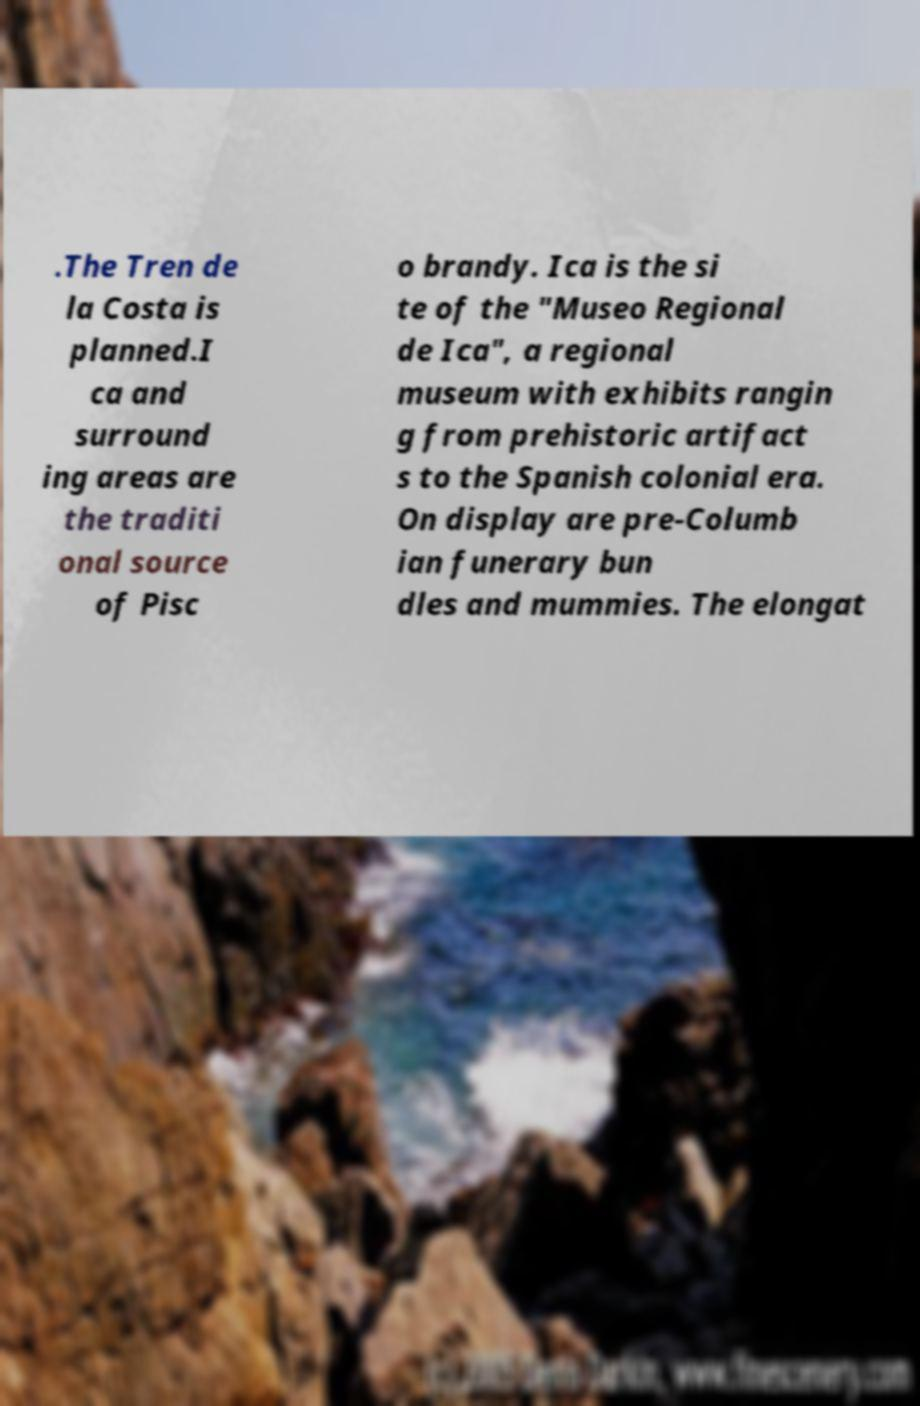Could you assist in decoding the text presented in this image and type it out clearly? .The Tren de la Costa is planned.I ca and surround ing areas are the traditi onal source of Pisc o brandy. Ica is the si te of the "Museo Regional de Ica", a regional museum with exhibits rangin g from prehistoric artifact s to the Spanish colonial era. On display are pre-Columb ian funerary bun dles and mummies. The elongat 